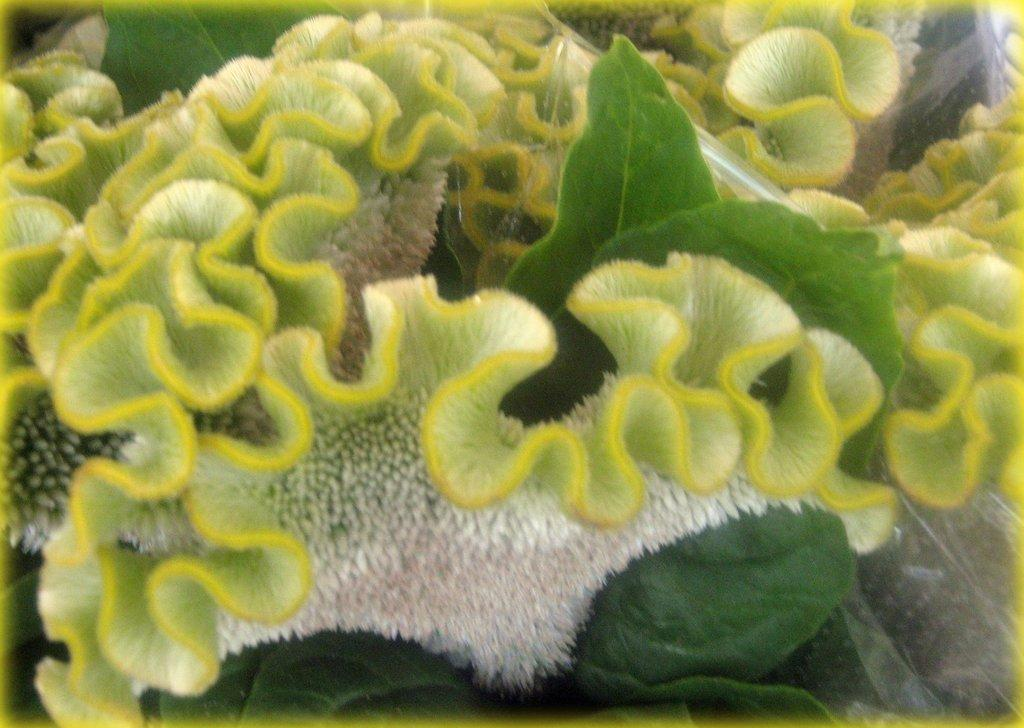What type of underwater environment is depicted in the image? There are coral reefs in the image, which indicates an underwater environment. What other natural elements can be seen in the image? There are leaves in the image. How many toes can be seen in the image? There are no toes visible in the image, as it features coral reefs and leaves. What angle is the image taken from? The angle from which the image is taken cannot be determined from the provided facts. 